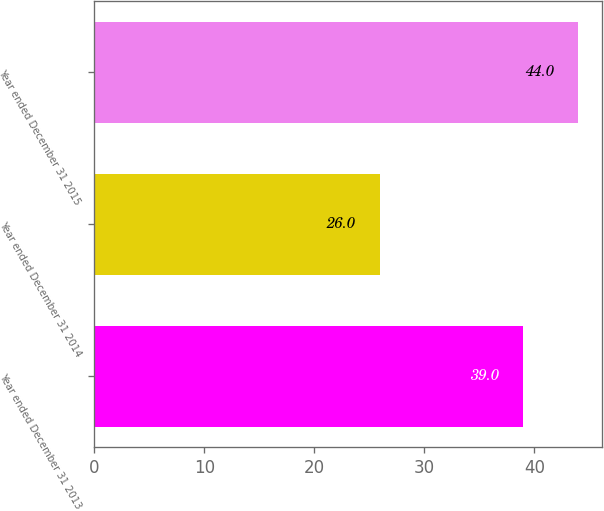Convert chart to OTSL. <chart><loc_0><loc_0><loc_500><loc_500><bar_chart><fcel>Year ended December 31 2013<fcel>Year ended December 31 2014<fcel>Year ended December 31 2015<nl><fcel>39<fcel>26<fcel>44<nl></chart> 